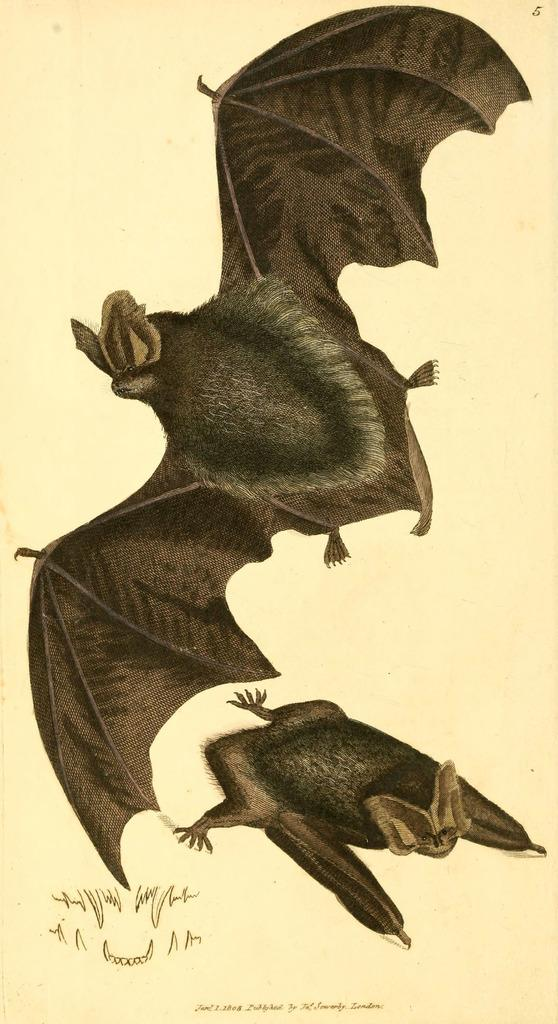What is the color of the paintings in the image? The paintings in the image are black. How many fingers can be seen in the image? There is no reference to fingers or any body parts in the image, so it is not possible to determine the number of fingers present. 